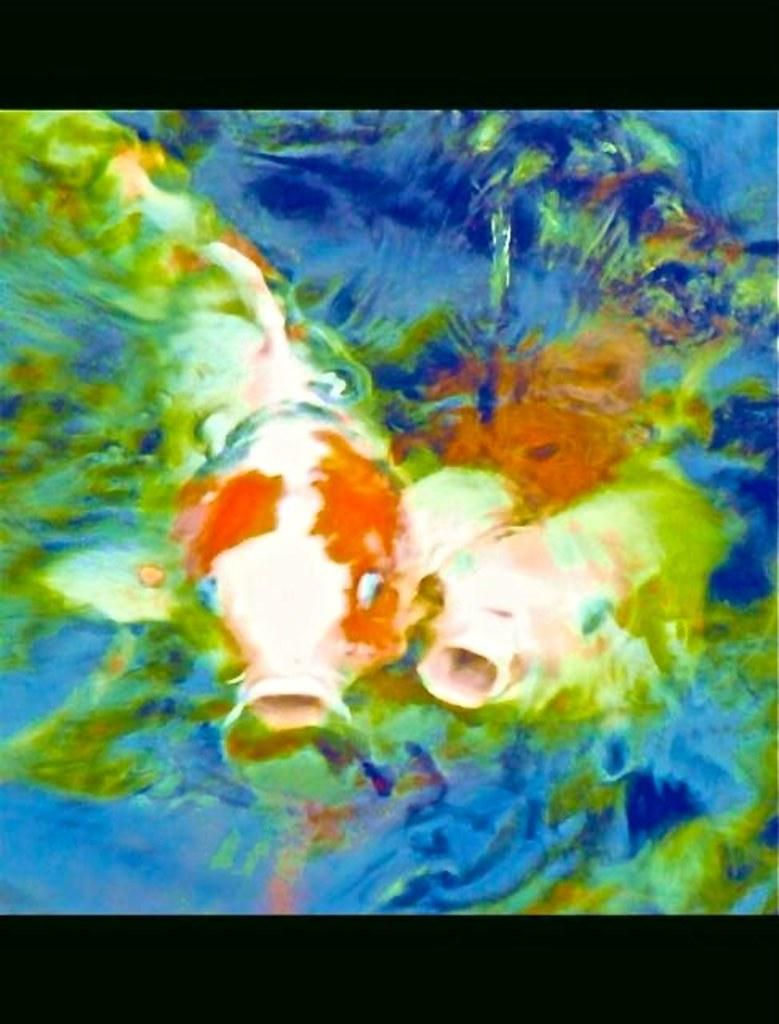What animals can be seen in the image? There are two fishes in the image. Where are the fishes located? The fishes are in the water. What color borders are present in the image? There is a black color border at the top and bottom of the image. What type of pancake is being cooked in the water with the fishes? There is no pancake present in the image; it only features two fishes in the water. 